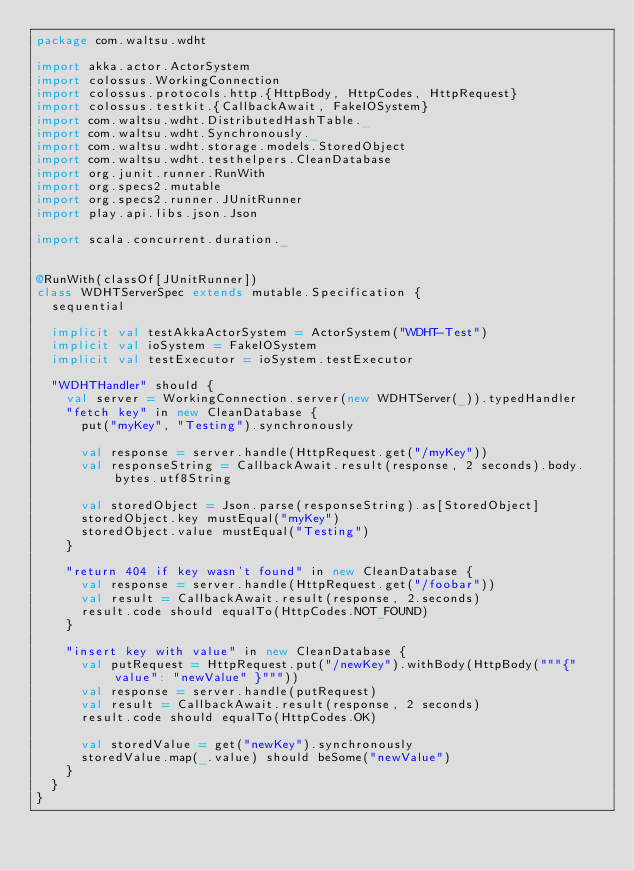Convert code to text. <code><loc_0><loc_0><loc_500><loc_500><_Scala_>package com.waltsu.wdht

import akka.actor.ActorSystem
import colossus.WorkingConnection
import colossus.protocols.http.{HttpBody, HttpCodes, HttpRequest}
import colossus.testkit.{CallbackAwait, FakeIOSystem}
import com.waltsu.wdht.DistributedHashTable._
import com.waltsu.wdht.Synchronously._
import com.waltsu.wdht.storage.models.StoredObject
import com.waltsu.wdht.testhelpers.CleanDatabase
import org.junit.runner.RunWith
import org.specs2.mutable
import org.specs2.runner.JUnitRunner
import play.api.libs.json.Json

import scala.concurrent.duration._


@RunWith(classOf[JUnitRunner])
class WDHTServerSpec extends mutable.Specification {
  sequential

  implicit val testAkkaActorSystem = ActorSystem("WDHT-Test")
  implicit val ioSystem = FakeIOSystem
  implicit val testExecutor = ioSystem.testExecutor

  "WDHTHandler" should {
    val server = WorkingConnection.server(new WDHTServer(_)).typedHandler
    "fetch key" in new CleanDatabase {
      put("myKey", "Testing").synchronously

      val response = server.handle(HttpRequest.get("/myKey"))
      val responseString = CallbackAwait.result(response, 2 seconds).body.bytes.utf8String

      val storedObject = Json.parse(responseString).as[StoredObject]
      storedObject.key mustEqual("myKey")
      storedObject.value mustEqual("Testing")
    }

    "return 404 if key wasn't found" in new CleanDatabase {
      val response = server.handle(HttpRequest.get("/foobar"))
      val result = CallbackAwait.result(response, 2.seconds)
      result.code should equalTo(HttpCodes.NOT_FOUND)
    }

    "insert key with value" in new CleanDatabase {
      val putRequest = HttpRequest.put("/newKey").withBody(HttpBody("""{"value": "newValue" }"""))
      val response = server.handle(putRequest)
      val result = CallbackAwait.result(response, 2 seconds)
      result.code should equalTo(HttpCodes.OK)

      val storedValue = get("newKey").synchronously
      storedValue.map(_.value) should beSome("newValue")
    }
  }
}
</code> 